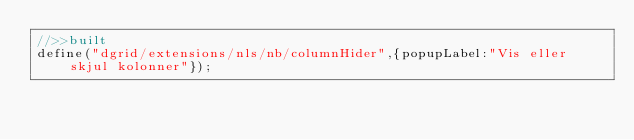<code> <loc_0><loc_0><loc_500><loc_500><_JavaScript_>//>>built
define("dgrid/extensions/nls/nb/columnHider",{popupLabel:"Vis eller skjul kolonner"});</code> 